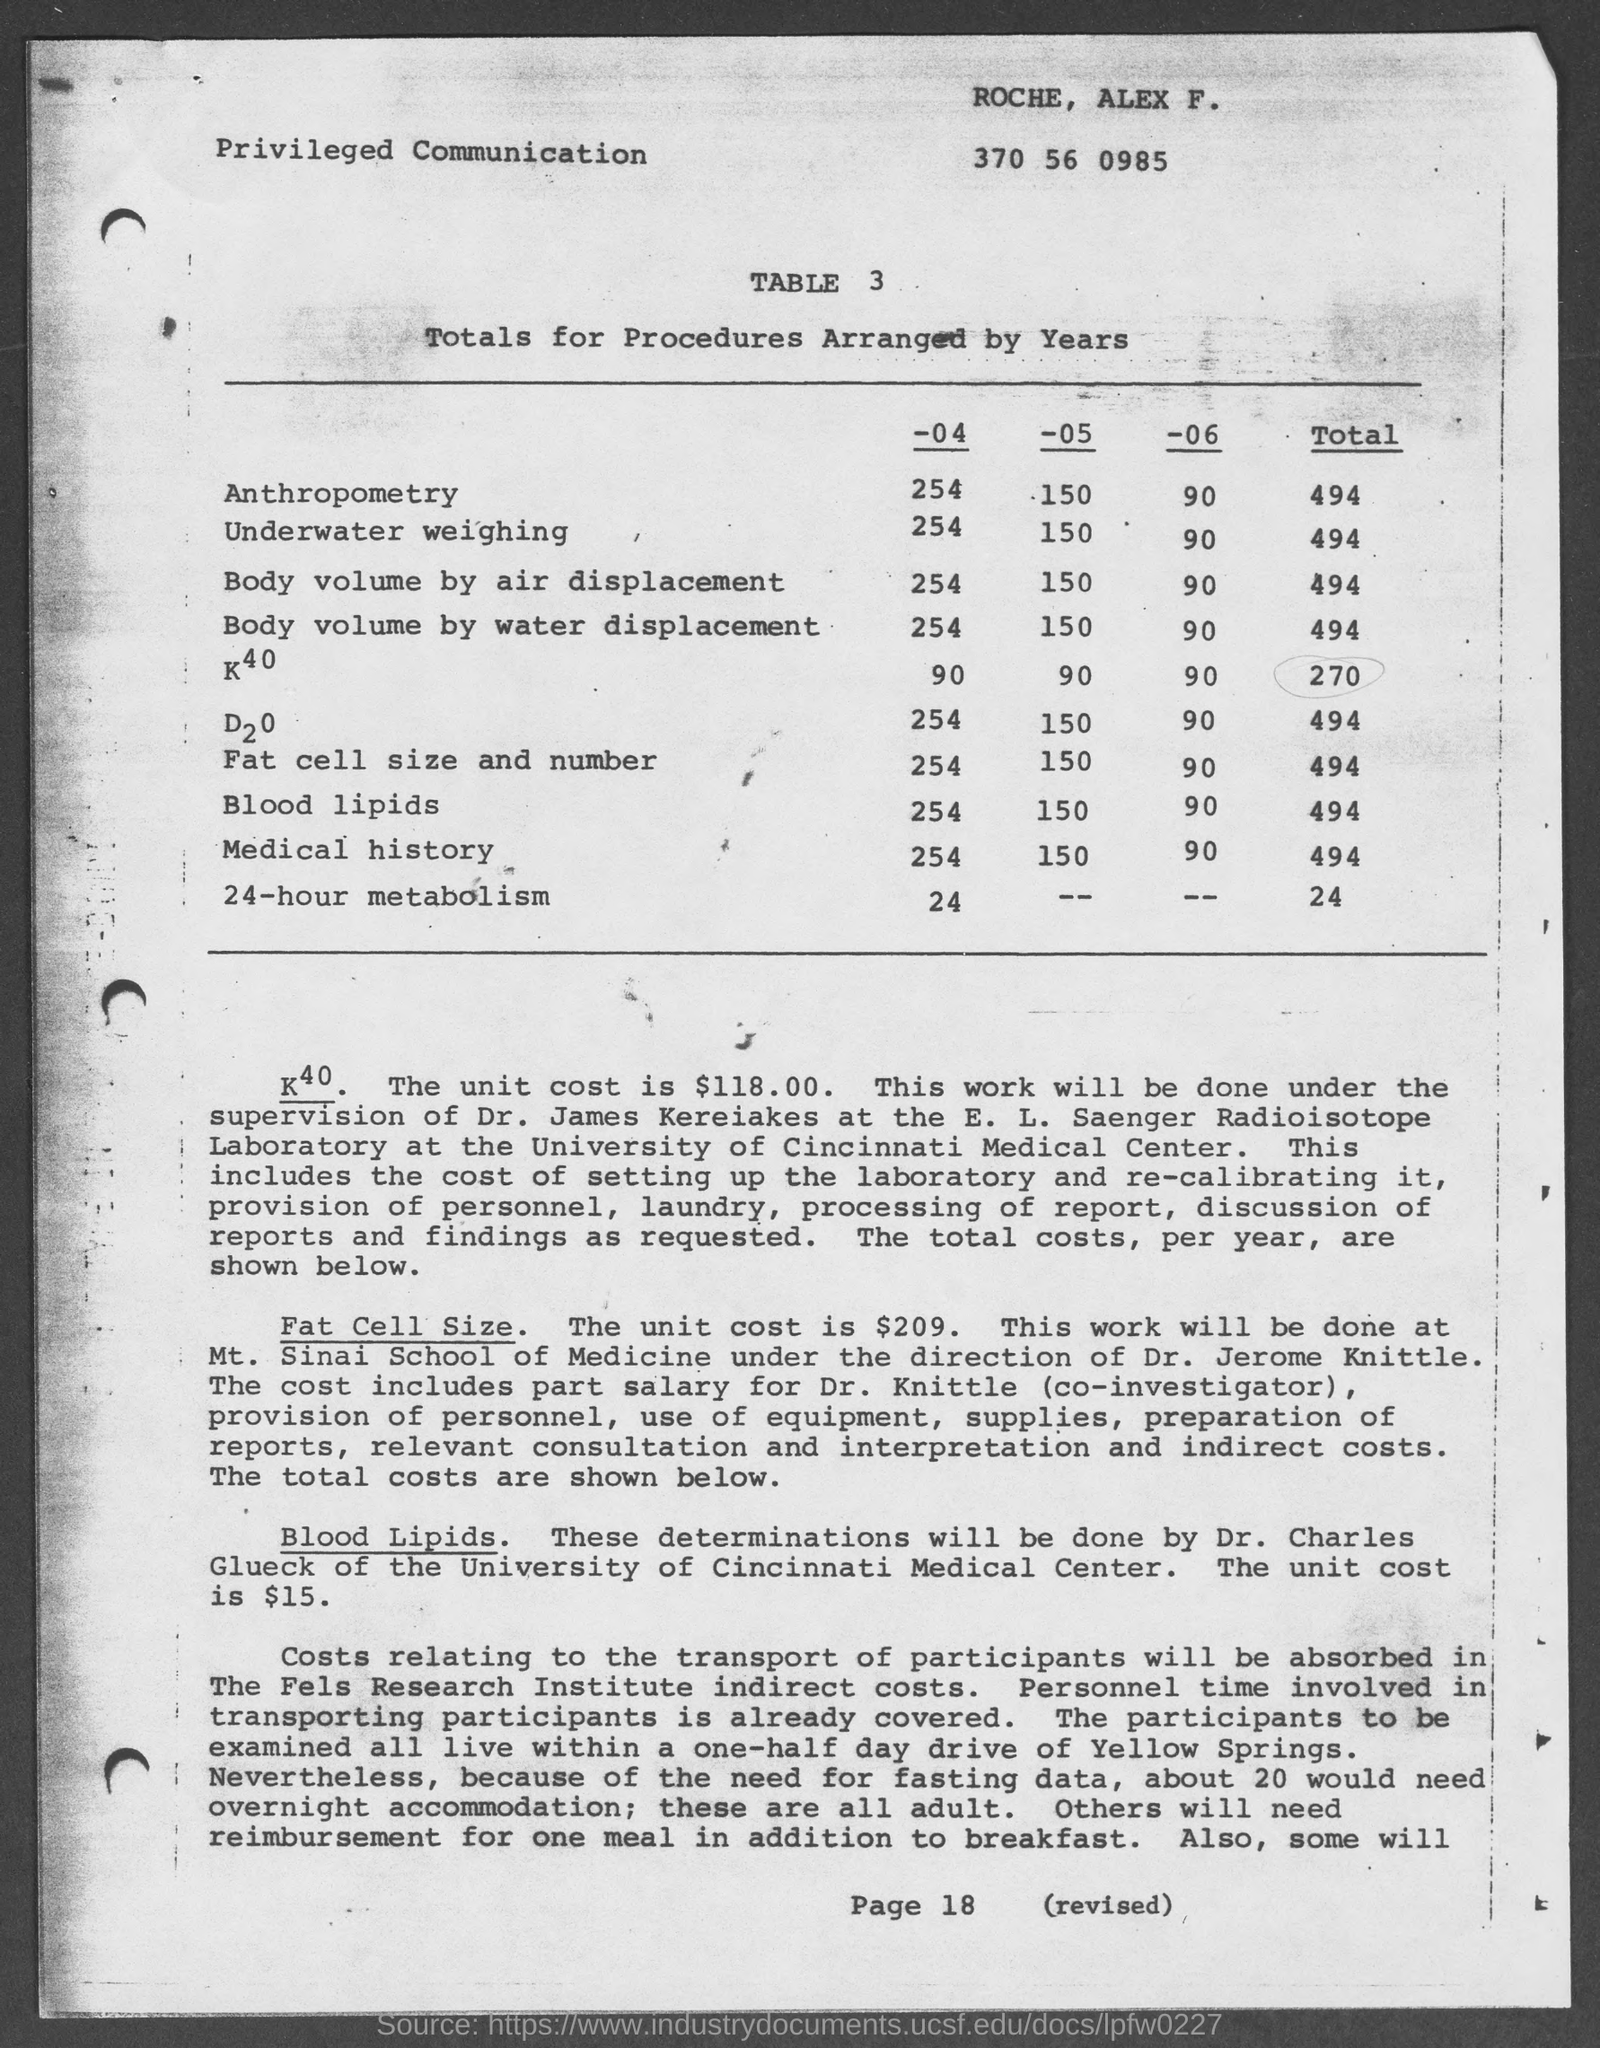Indicate a few pertinent items in this graphic. The total value of body volume by air displacement is 494. The total value of 24-hour metabolism is 24. The total value of anthropometry is 494. The total volume of a person's body can be calculated using the principle of water displacement, which involves measuring the volume of water displaced by the body. The value of this measurement is 494. The total value of underwater weighing is 494. 